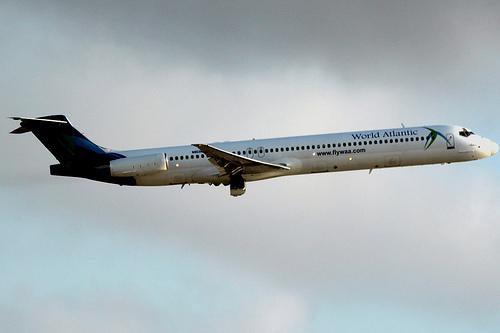Question: who flies the plane?
Choices:
A. Pilot.
B. Co-pilot.
C. Hijacker.
D. Hal Jordan.
Answer with the letter. Answer: A Question: what color is the tail?
Choices:
A. Red.
B. Blue.
C. Yellow.
D. Orange.
Answer with the letter. Answer: B 